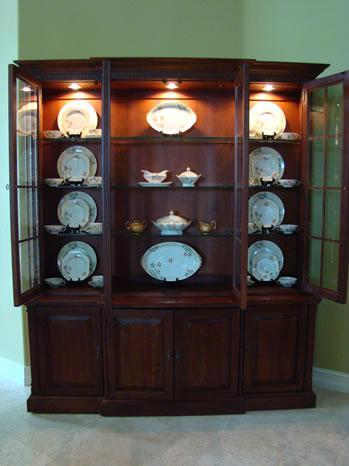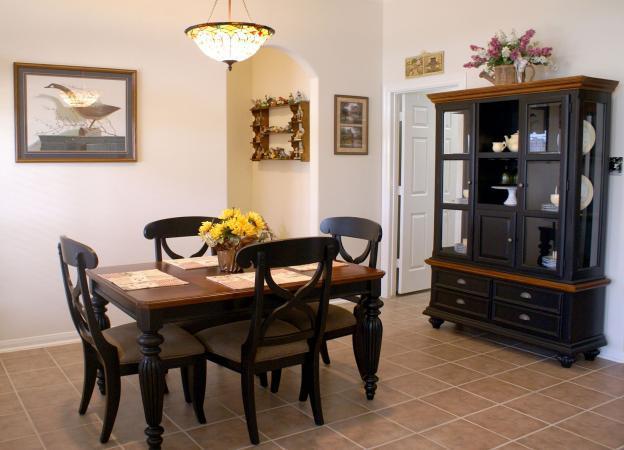The first image is the image on the left, the second image is the image on the right. Assess this claim about the two images: "One of the cabinets against the wall is white.". Correct or not? Answer yes or no. No. The first image is the image on the left, the second image is the image on the right. Considering the images on both sides, is "An image shows a white cabinet with feet and a scroll-curved bottom." valid? Answer yes or no. No. 